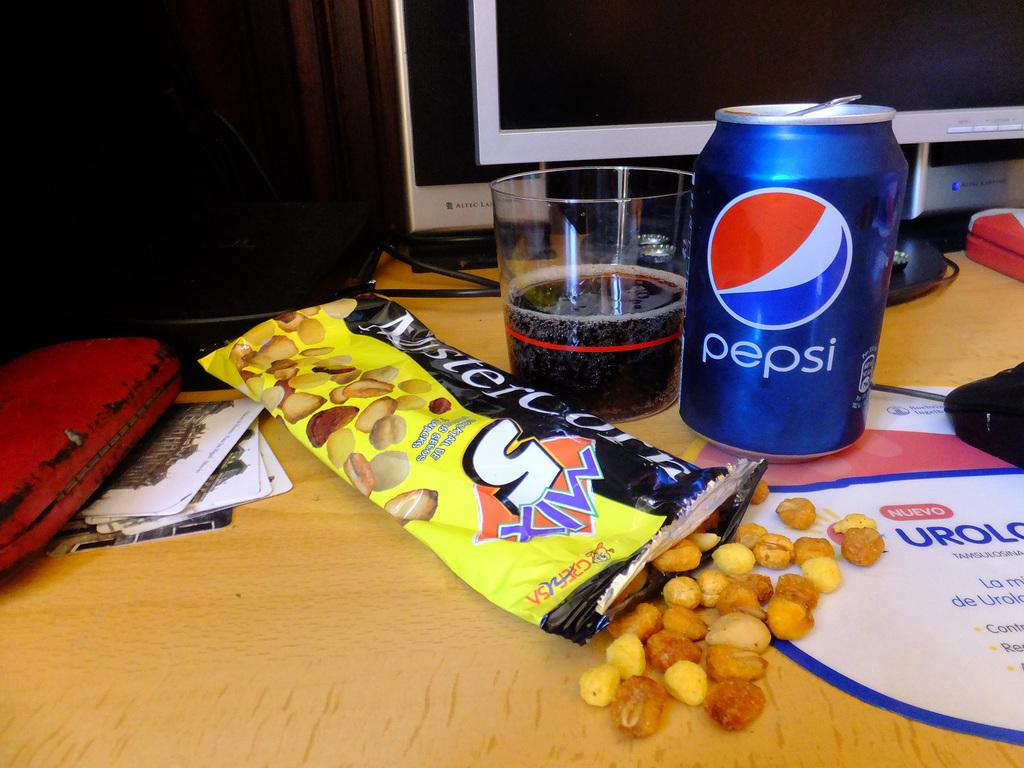What type of food is visible in the image? There is food in the image, but the specific type cannot be determined from the facts provided. What type of container is present in the image? There is a tin in the image. What type of drinking vessel is present in the image? There is a glass in the image. Where are all the items located in the image? All items are on a table in the image. What system is present in the image? There is a system in the image, but its nature cannot be determined from the facts provided. What other objects are present in the image? There are additional objects in the image, but their specific nature cannot be determined from the facts provided. What type of sponge is being used to clean the roof in the image? There is no sponge or roof present in the image. What type of zephyr can be seen blowing through the scene in the image? There is no zephyr present in the image. 